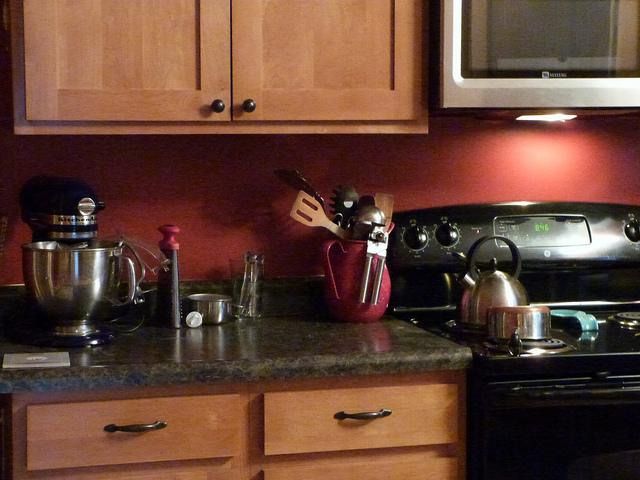What fuels the stove?

Choices:
A) gas
B) charcoal
C) microwave
D) electricity electricity 